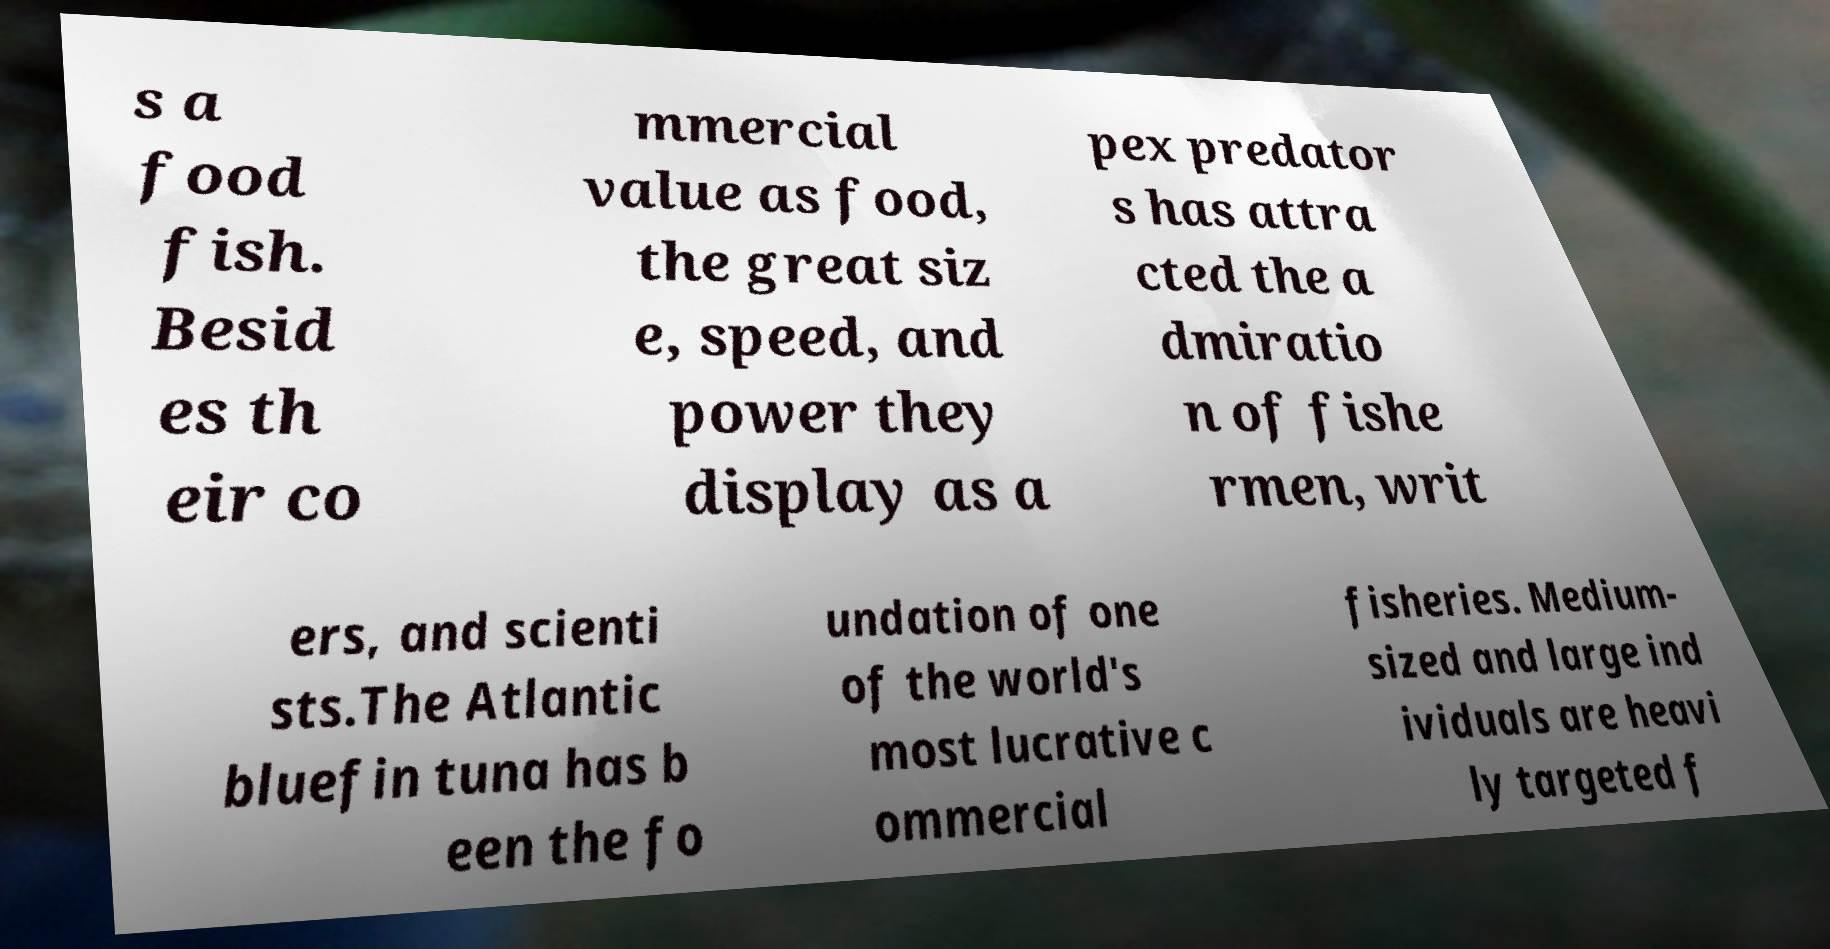What messages or text are displayed in this image? I need them in a readable, typed format. s a food fish. Besid es th eir co mmercial value as food, the great siz e, speed, and power they display as a pex predator s has attra cted the a dmiratio n of fishe rmen, writ ers, and scienti sts.The Atlantic bluefin tuna has b een the fo undation of one of the world's most lucrative c ommercial fisheries. Medium- sized and large ind ividuals are heavi ly targeted f 